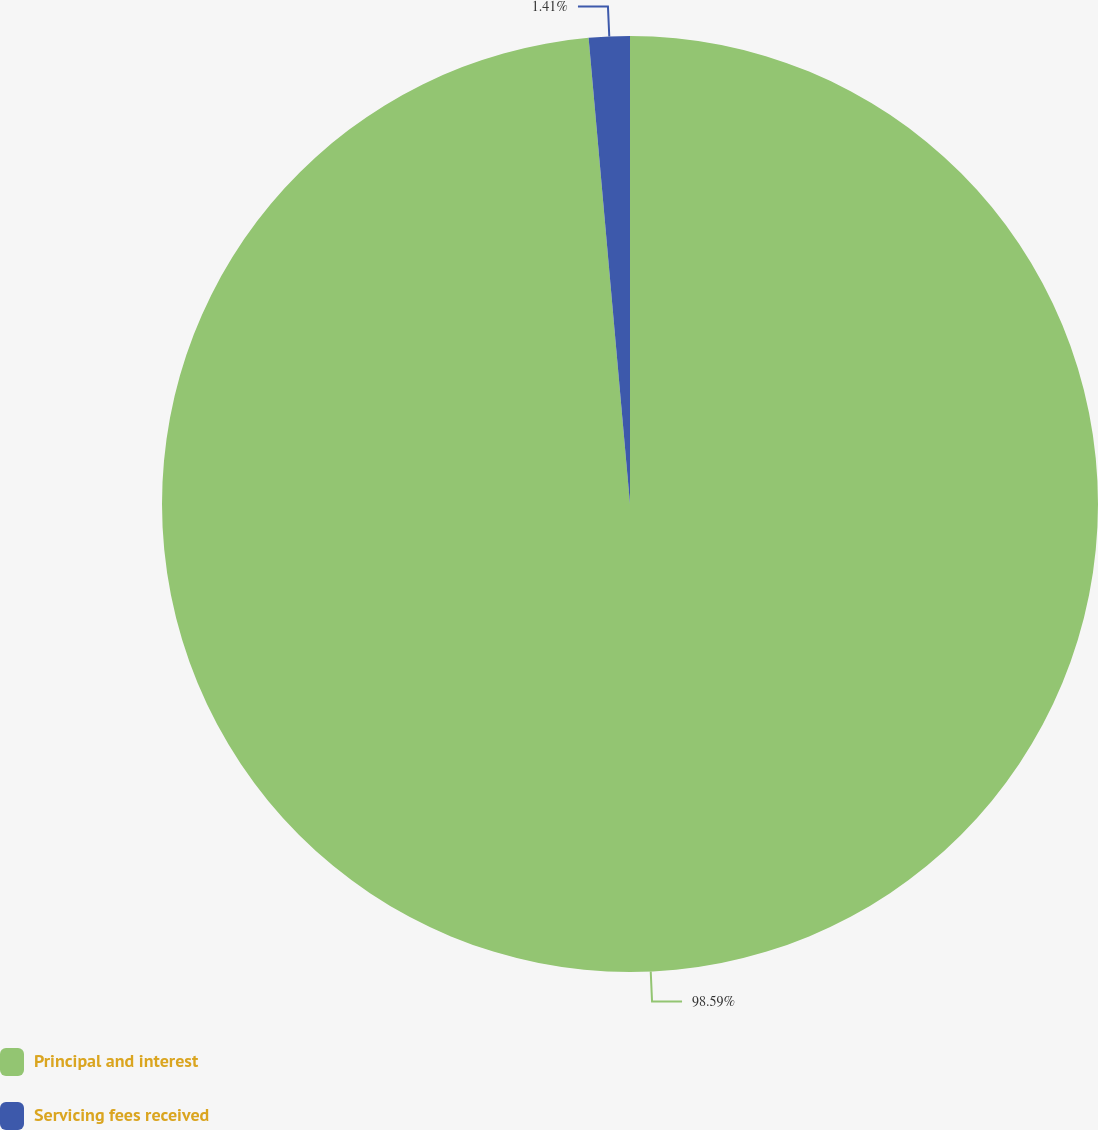<chart> <loc_0><loc_0><loc_500><loc_500><pie_chart><fcel>Principal and interest<fcel>Servicing fees received<nl><fcel>98.59%<fcel>1.41%<nl></chart> 